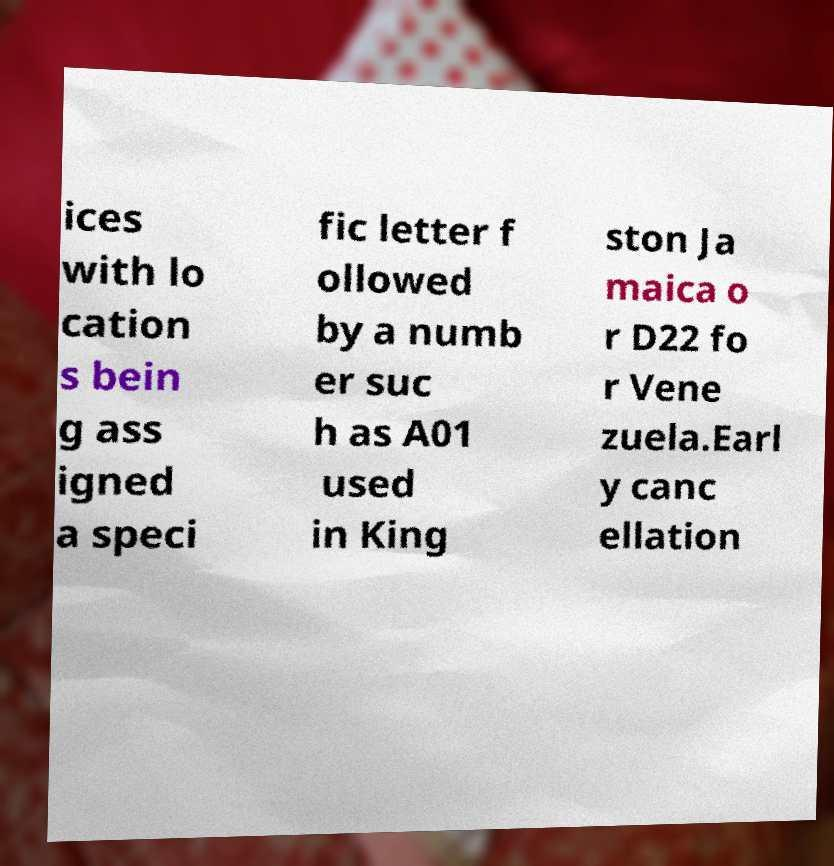Can you read and provide the text displayed in the image?This photo seems to have some interesting text. Can you extract and type it out for me? ices with lo cation s bein g ass igned a speci fic letter f ollowed by a numb er suc h as A01 used in King ston Ja maica o r D22 fo r Vene zuela.Earl y canc ellation 